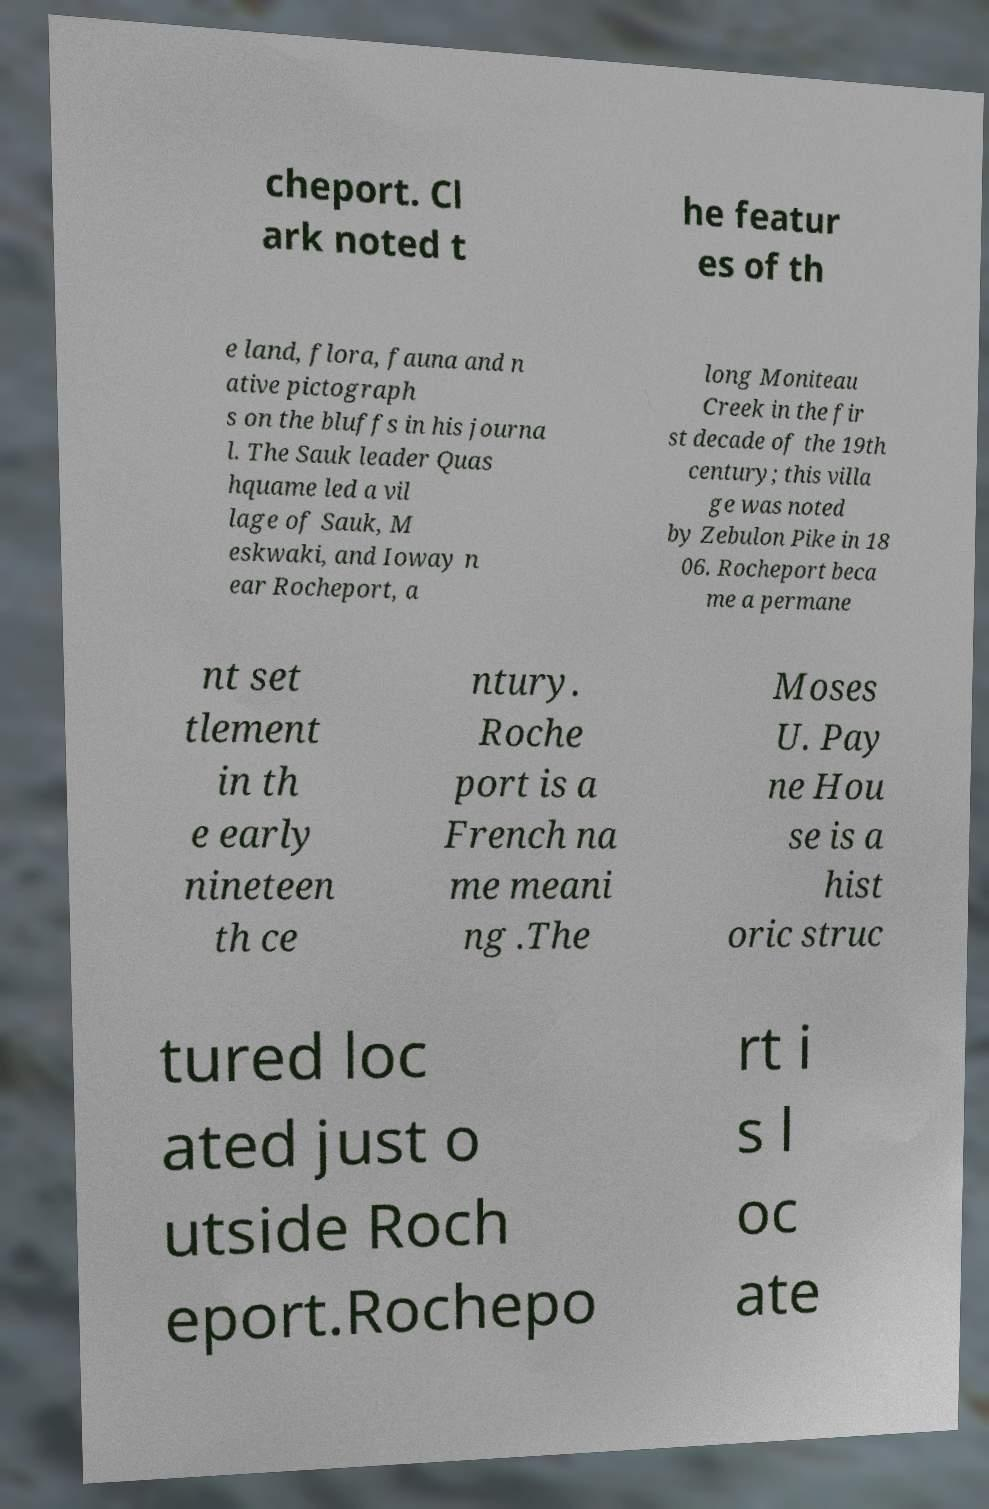Please read and relay the text visible in this image. What does it say? cheport. Cl ark noted t he featur es of th e land, flora, fauna and n ative pictograph s on the bluffs in his journa l. The Sauk leader Quas hquame led a vil lage of Sauk, M eskwaki, and Ioway n ear Rocheport, a long Moniteau Creek in the fir st decade of the 19th century; this villa ge was noted by Zebulon Pike in 18 06. Rocheport beca me a permane nt set tlement in th e early nineteen th ce ntury. Roche port is a French na me meani ng .The Moses U. Pay ne Hou se is a hist oric struc tured loc ated just o utside Roch eport.Rochepo rt i s l oc ate 